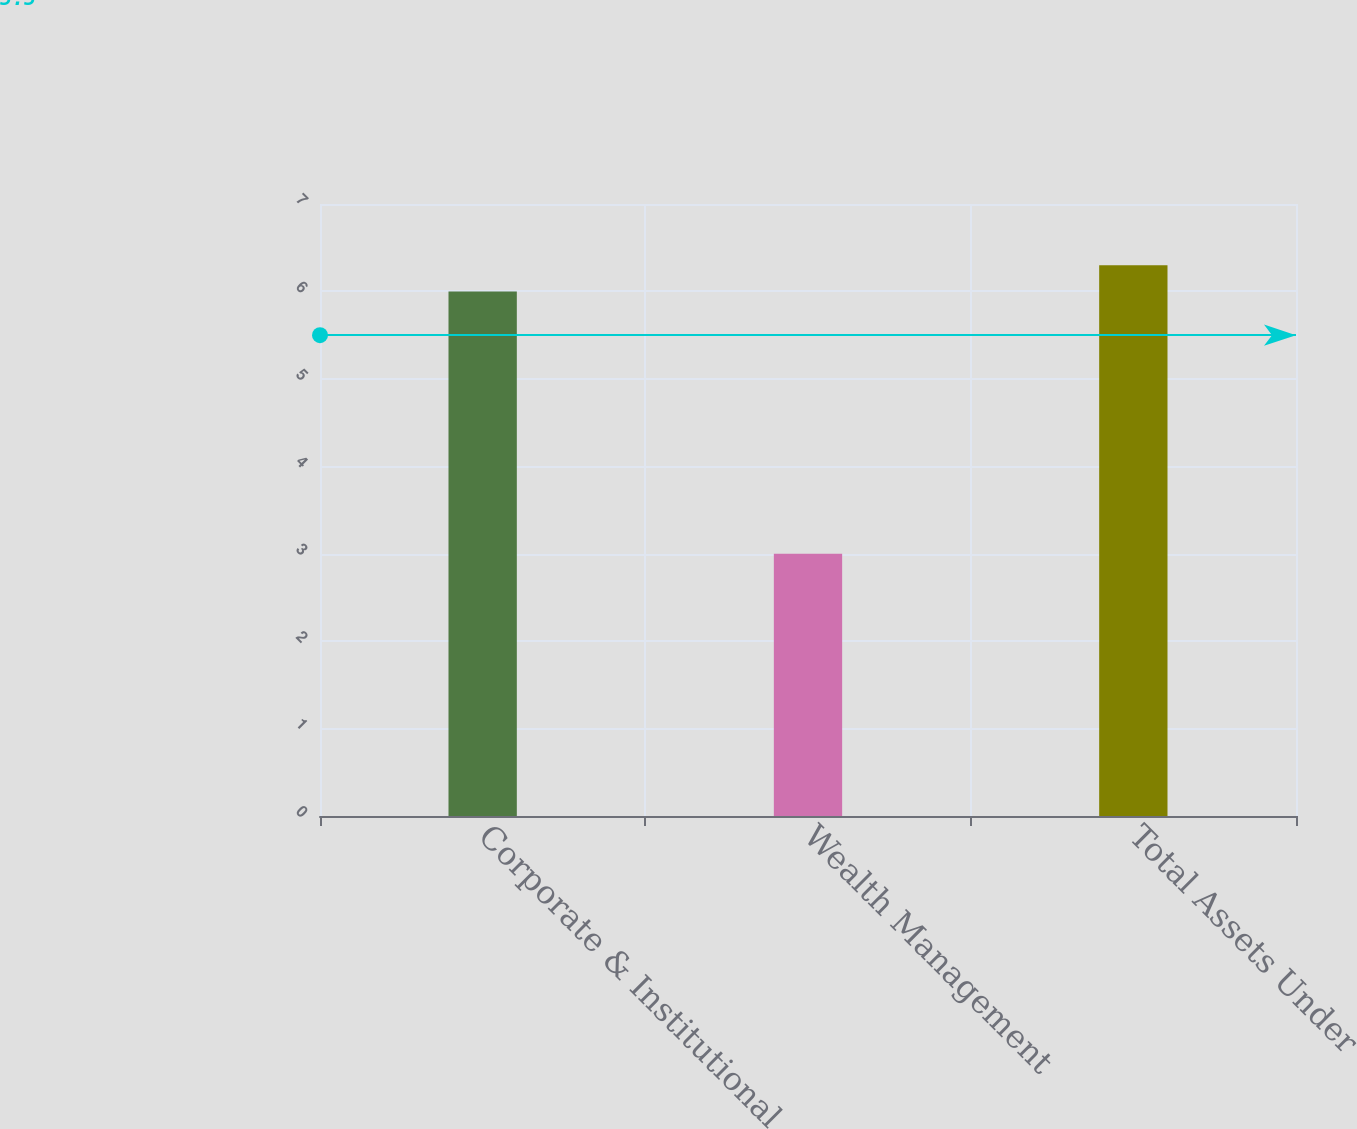Convert chart to OTSL. <chart><loc_0><loc_0><loc_500><loc_500><bar_chart><fcel>Corporate & Institutional<fcel>Wealth Management<fcel>Total Assets Under<nl><fcel>6<fcel>3<fcel>6.3<nl></chart> 